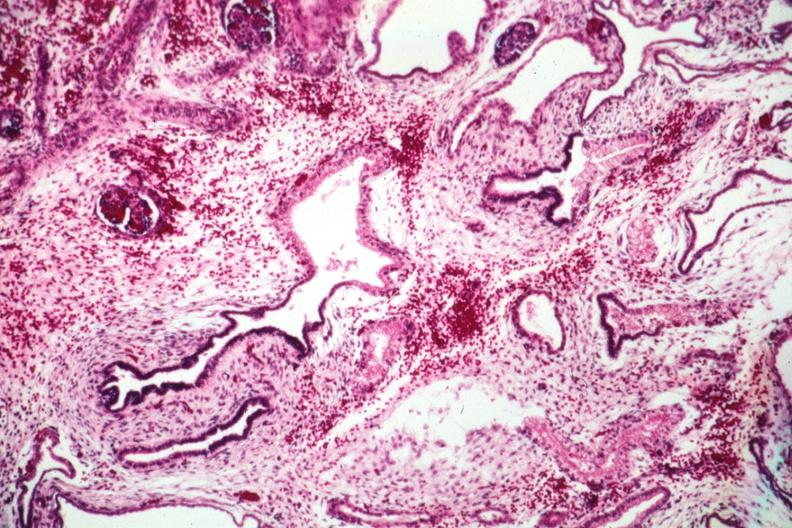what is present?
Answer the question using a single word or phrase. Kidney 